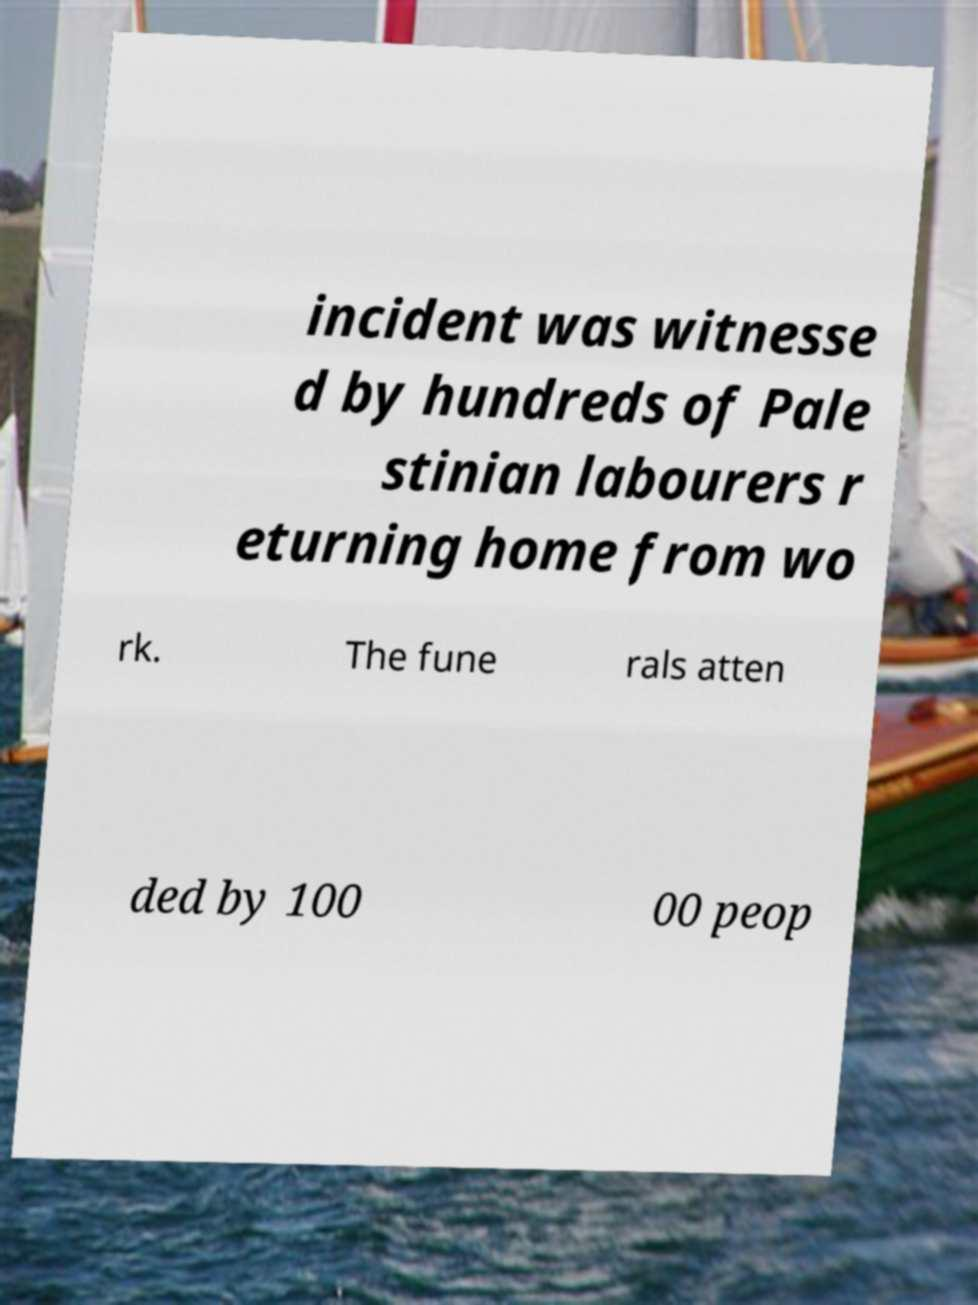What messages or text are displayed in this image? I need them in a readable, typed format. incident was witnesse d by hundreds of Pale stinian labourers r eturning home from wo rk. The fune rals atten ded by 100 00 peop 